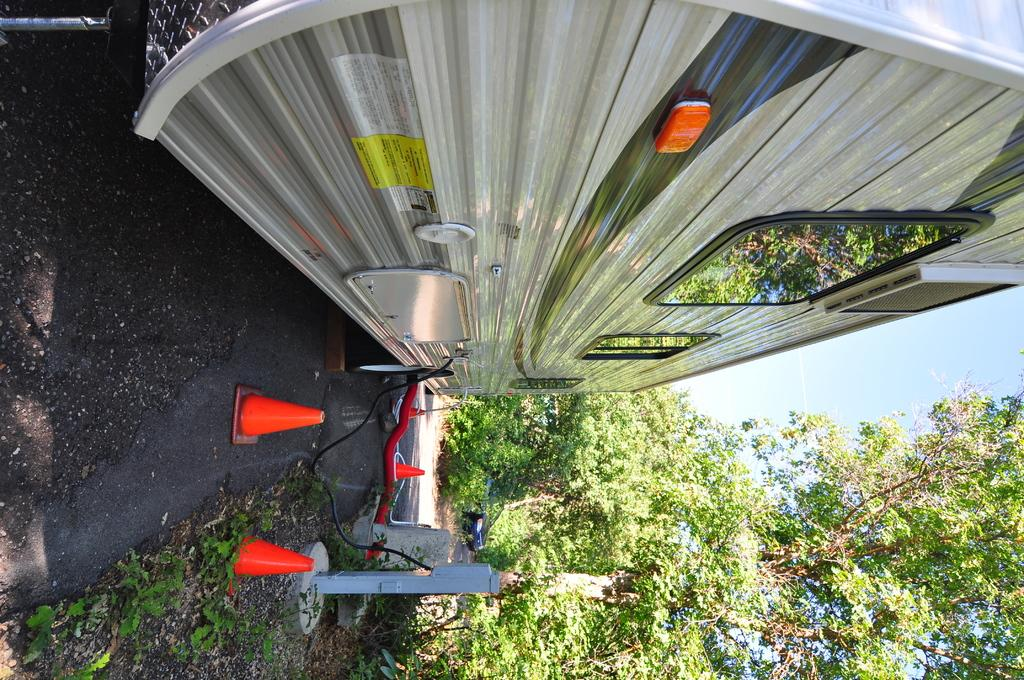What type of vehicle is in the image? There is a van in the image. Where is the van located in the image? The van is at the top side of the image. What type of natural elements are present in the image? There are trees in the image. Where are the trees located in the image? The trees are at the bottom side of the image. What objects are present to guide or control traffic in the image? There are traffic cones in the image. Where are the traffic cones located in the image? The traffic cones are at the bottom side of the image. What direction is the goose flying in the image? There is no goose present in the image. What type of event is taking place in the image? The image does not depict any specific event; it shows a van, trees, and traffic cones. 